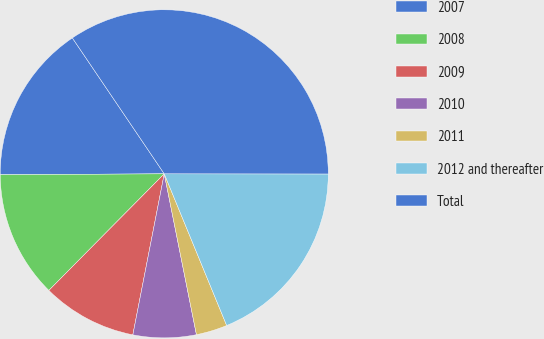<chart> <loc_0><loc_0><loc_500><loc_500><pie_chart><fcel>2007<fcel>2008<fcel>2009<fcel>2010<fcel>2011<fcel>2012 and thereafter<fcel>Total<nl><fcel>15.63%<fcel>12.49%<fcel>9.35%<fcel>6.21%<fcel>3.07%<fcel>18.77%<fcel>34.48%<nl></chart> 